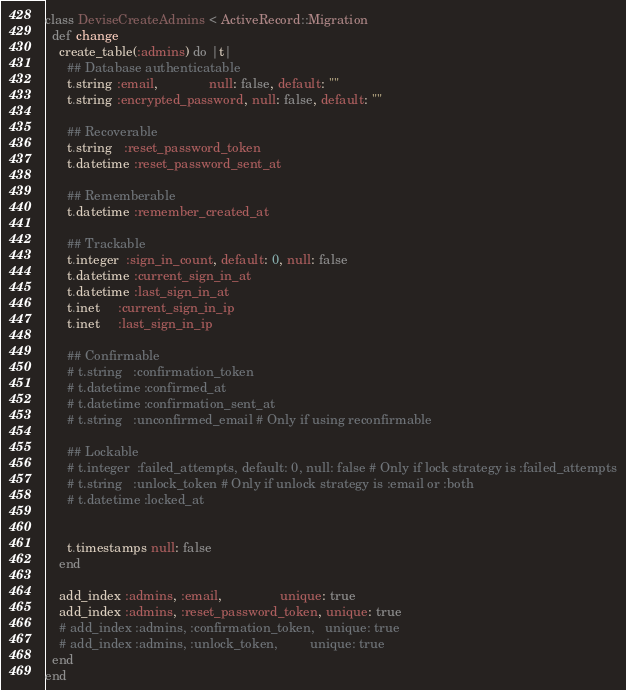<code> <loc_0><loc_0><loc_500><loc_500><_Ruby_>class DeviseCreateAdmins < ActiveRecord::Migration
  def change
    create_table(:admins) do |t|
      ## Database authenticatable
      t.string :email,              null: false, default: ""
      t.string :encrypted_password, null: false, default: ""

      ## Recoverable
      t.string   :reset_password_token
      t.datetime :reset_password_sent_at

      ## Rememberable
      t.datetime :remember_created_at

      ## Trackable
      t.integer  :sign_in_count, default: 0, null: false
      t.datetime :current_sign_in_at
      t.datetime :last_sign_in_at
      t.inet     :current_sign_in_ip
      t.inet     :last_sign_in_ip

      ## Confirmable
      # t.string   :confirmation_token
      # t.datetime :confirmed_at
      # t.datetime :confirmation_sent_at
      # t.string   :unconfirmed_email # Only if using reconfirmable

      ## Lockable
      # t.integer  :failed_attempts, default: 0, null: false # Only if lock strategy is :failed_attempts
      # t.string   :unlock_token # Only if unlock strategy is :email or :both
      # t.datetime :locked_at


      t.timestamps null: false
    end

    add_index :admins, :email,                unique: true
    add_index :admins, :reset_password_token, unique: true
    # add_index :admins, :confirmation_token,   unique: true
    # add_index :admins, :unlock_token,         unique: true
  end
end
</code> 